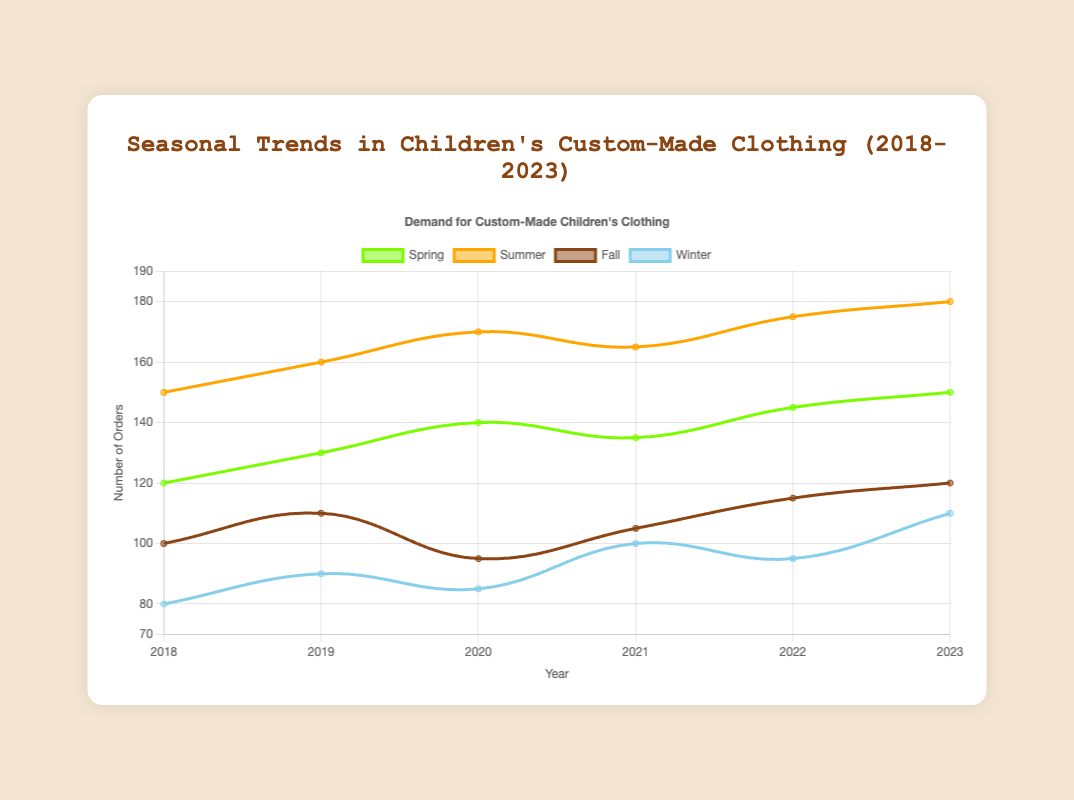What year had the highest demand for custom-made clothing in Summer? To find this, look at the Summer dataset and pick the year with the highest value. The highest demand in Summer is in 2023 with 180 orders.
Answer: 2023 Which season had the lowest demand in 2018? Check the values for each season in 2018 and compare them. Winter had the lowest demand with 80 orders.
Answer: Winter What is the average demand for Spring from 2018 to 2023? Add the Spring values from each year (120 + 130 + 140 + 135 + 145 + 150) and divide by the number of years, which is 6. The calculation is (120 + 130 + 140 + 135 + 145 + 150) / 6 = 820 / 6 ≈ 136.67.
Answer: 136.67 How did the demand in Fall change from 2020 to 2023? Observe the Fall demand values for 2020 and 2023. In 2020, it was 95, and in 2023, it increased to 120, showing an increase of 25 orders.
Answer: Increased by 25 Which year exhibited the highest overall demand across all seasons? Sum the demands for each year and compare them: 
- 2018: 450 (120 + 150 + 100 + 80)
- 2019: 490 (130 + 160 + 110 + 90)
- 2020: 490 (140 + 170 + 95 + 85)
- 2021: 505 (135 + 165 + 105 + 100)
- 2022: 530 (145 + 175 + 115 + 95)
- 2023: 560 (150 + 180 + 120 + 110)
2023 has the highest overall demand.
Answer: 2023 Which season shows the most consistent demand over the years? Check the fluctuations in demand for each season across the years by calculating their range (highest demand minus lowest demand):
- Spring: 150 - 120 = 30
- Summer: 180 - 150 = 30
- Fall: 120 - 95 = 25
- Winter: 110 - 80 = 30
Fall shows the most consistent demand with the smallest range.
Answer: Fall 